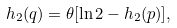Convert formula to latex. <formula><loc_0><loc_0><loc_500><loc_500>h _ { 2 } ( q ) = \theta [ \ln 2 - h _ { 2 } ( p ) ] ,</formula> 